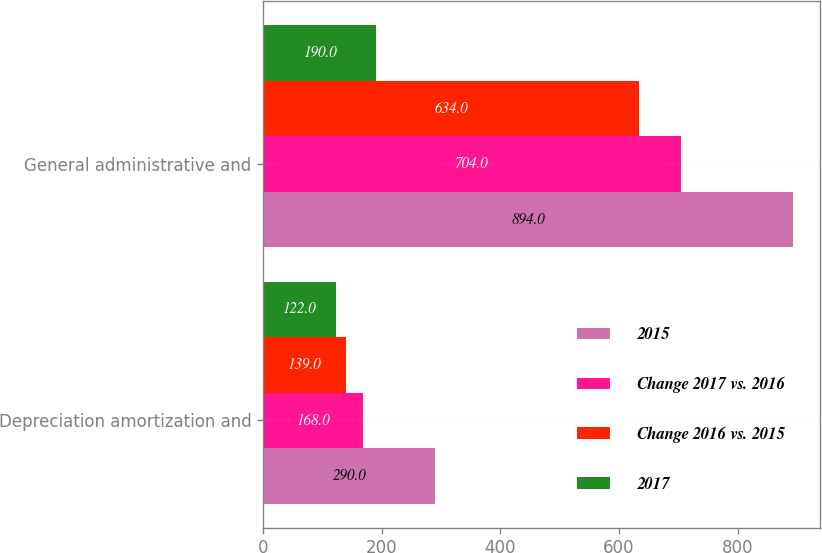Convert chart. <chart><loc_0><loc_0><loc_500><loc_500><stacked_bar_chart><ecel><fcel>Depreciation amortization and<fcel>General administrative and<nl><fcel>2015<fcel>290<fcel>894<nl><fcel>Change 2017 vs. 2016<fcel>168<fcel>704<nl><fcel>Change 2016 vs. 2015<fcel>139<fcel>634<nl><fcel>2017<fcel>122<fcel>190<nl></chart> 